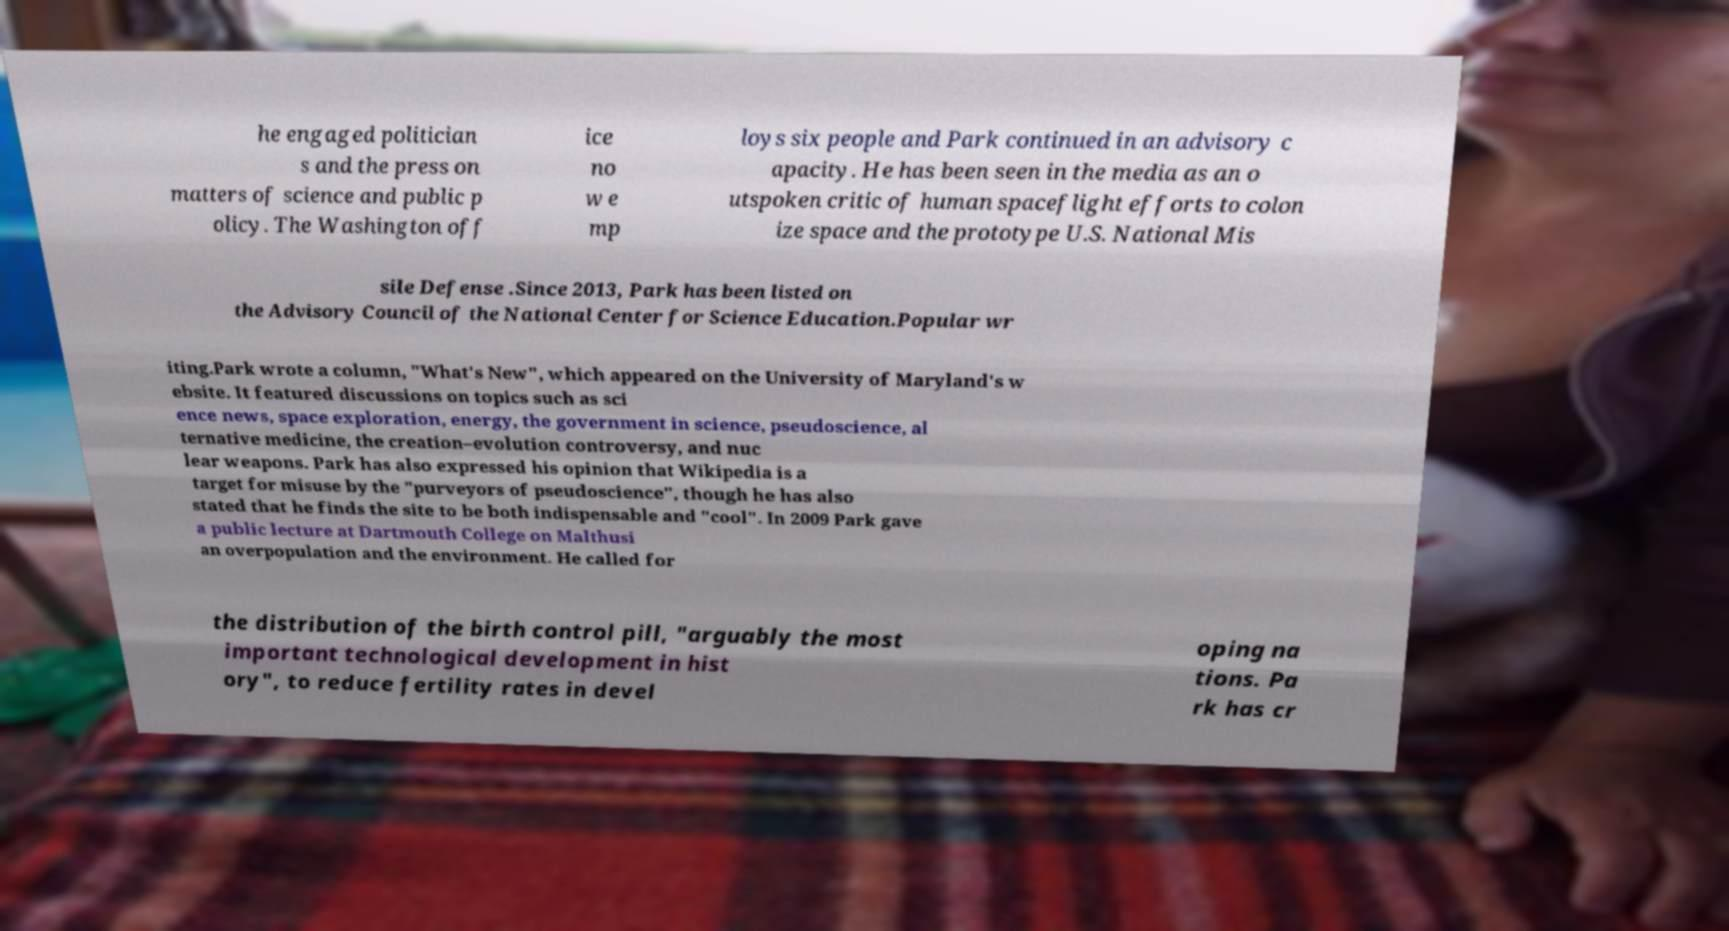Could you extract and type out the text from this image? he engaged politician s and the press on matters of science and public p olicy. The Washington off ice no w e mp loys six people and Park continued in an advisory c apacity. He has been seen in the media as an o utspoken critic of human spaceflight efforts to colon ize space and the prototype U.S. National Mis sile Defense .Since 2013, Park has been listed on the Advisory Council of the National Center for Science Education.Popular wr iting.Park wrote a column, "What's New", which appeared on the University of Maryland's w ebsite. It featured discussions on topics such as sci ence news, space exploration, energy, the government in science, pseudoscience, al ternative medicine, the creation–evolution controversy, and nuc lear weapons. Park has also expressed his opinion that Wikipedia is a target for misuse by the "purveyors of pseudoscience", though he has also stated that he finds the site to be both indispensable and "cool". In 2009 Park gave a public lecture at Dartmouth College on Malthusi an overpopulation and the environment. He called for the distribution of the birth control pill, "arguably the most important technological development in hist ory", to reduce fertility rates in devel oping na tions. Pa rk has cr 